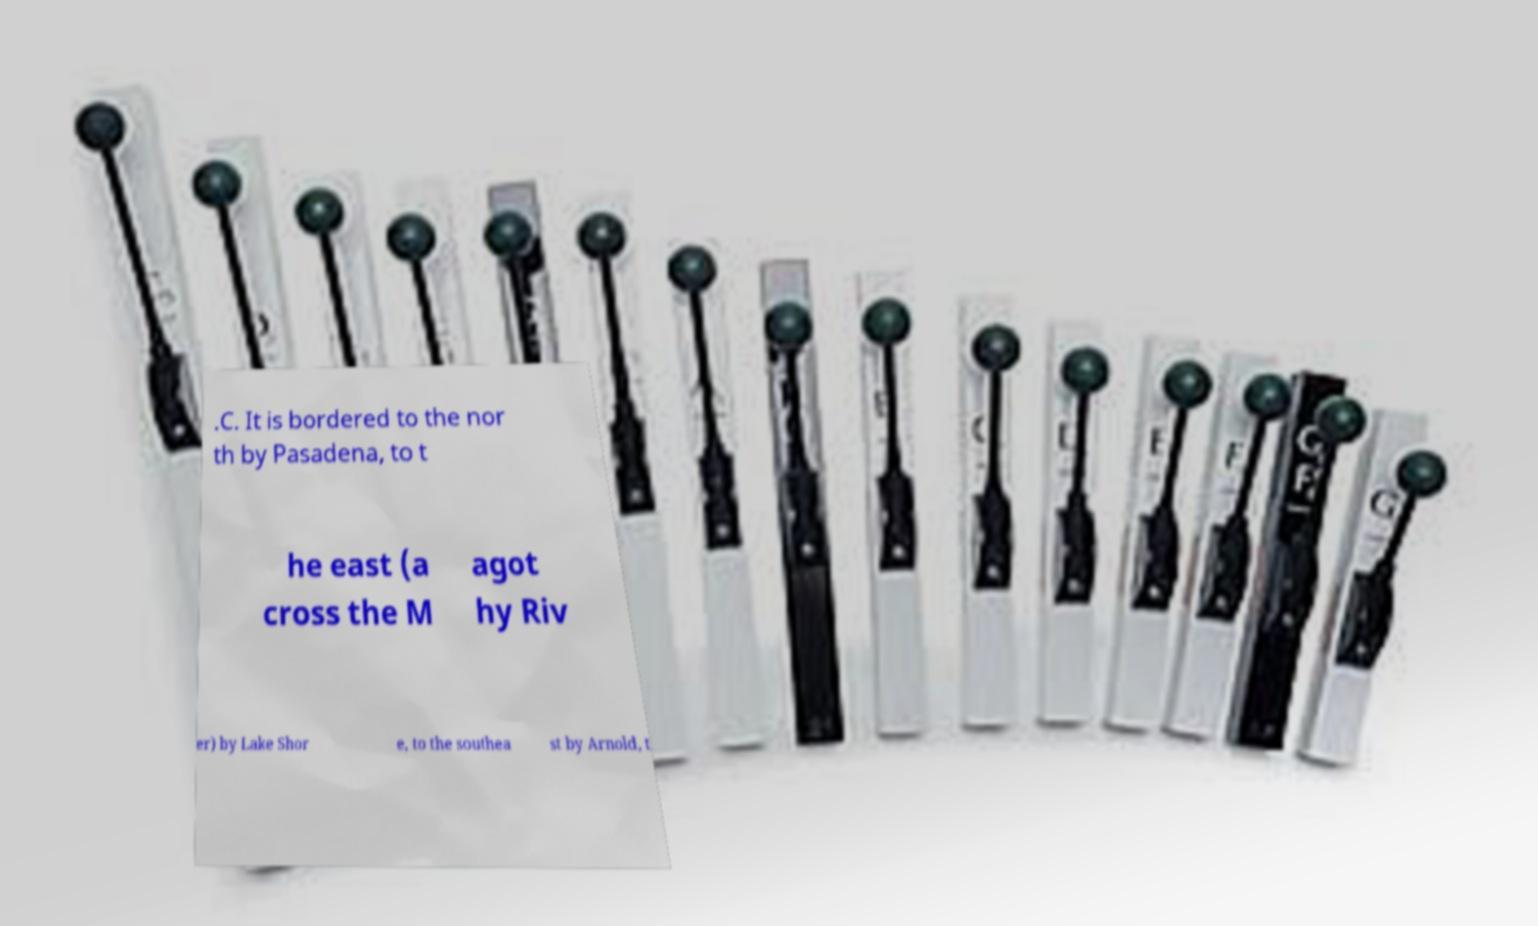Please identify and transcribe the text found in this image. .C. It is bordered to the nor th by Pasadena, to t he east (a cross the M agot hy Riv er) by Lake Shor e, to the southea st by Arnold, t 